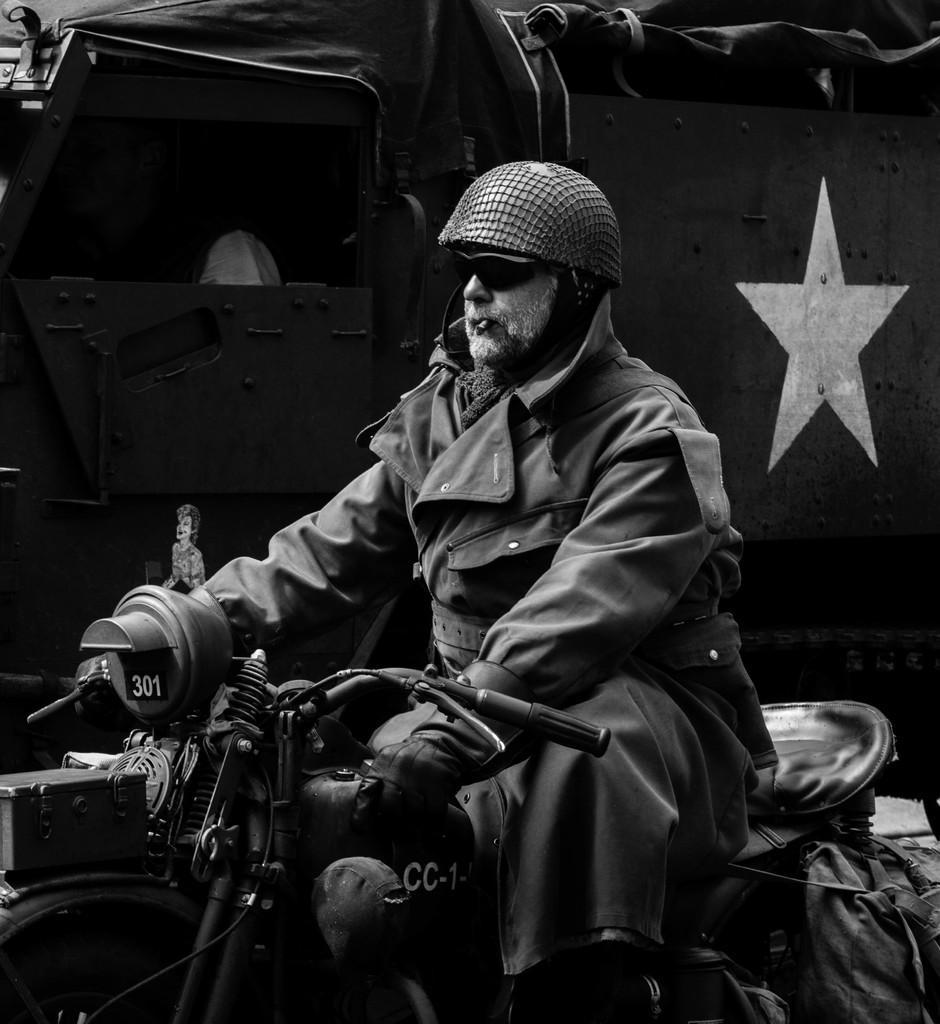Can you describe this image briefly? Here in this picture we can see a man sitting on a motor bike and we can see he is having a cigarette in his mouth and wearing a helmet and goggles and beside him we can see a truck present. 